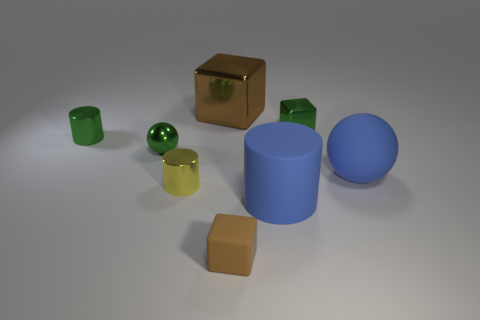Subtract all small green metal cubes. How many cubes are left? 2 Subtract all brown blocks. How many blocks are left? 1 Subtract 2 cylinders. How many cylinders are left? 1 Add 1 big yellow metallic objects. How many objects exist? 9 Subtract all blocks. How many objects are left? 5 Subtract all blue cubes. Subtract all cyan cylinders. How many cubes are left? 3 Subtract all yellow balls. How many purple cylinders are left? 0 Subtract all green spheres. Subtract all small metallic cylinders. How many objects are left? 5 Add 8 large blue rubber balls. How many large blue rubber balls are left? 9 Add 8 green blocks. How many green blocks exist? 9 